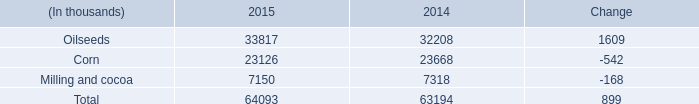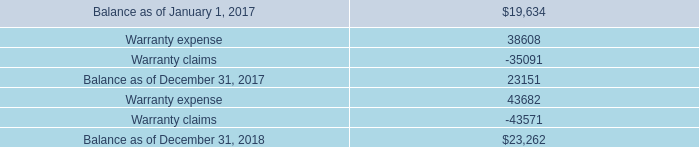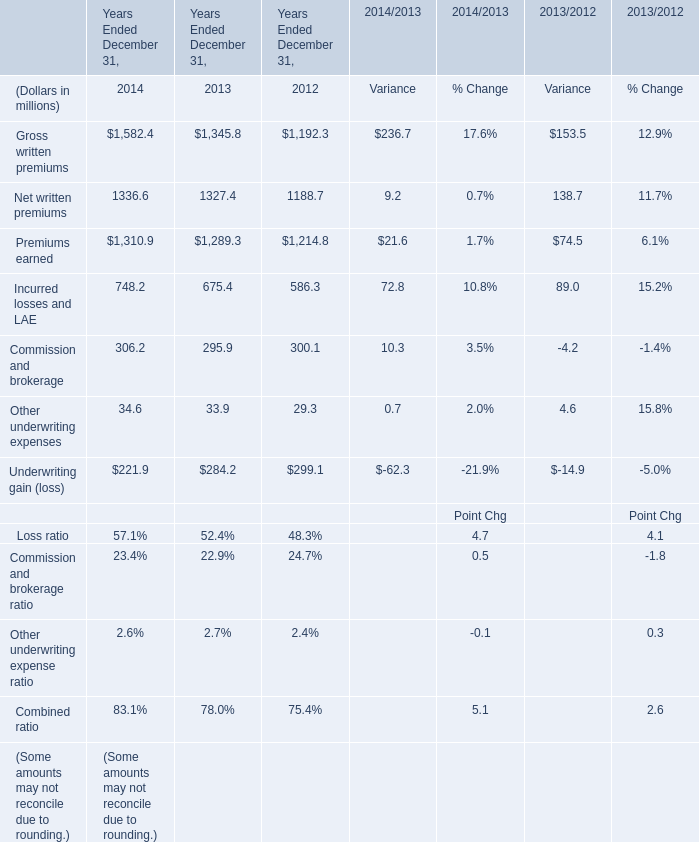what was the percent of the total self-insurance reserves that was classified as current in 2018 
Computations: (52 / 105)
Answer: 0.49524. 